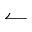<formula> <loc_0><loc_0><loc_500><loc_500>\leftharpoonup</formula> 